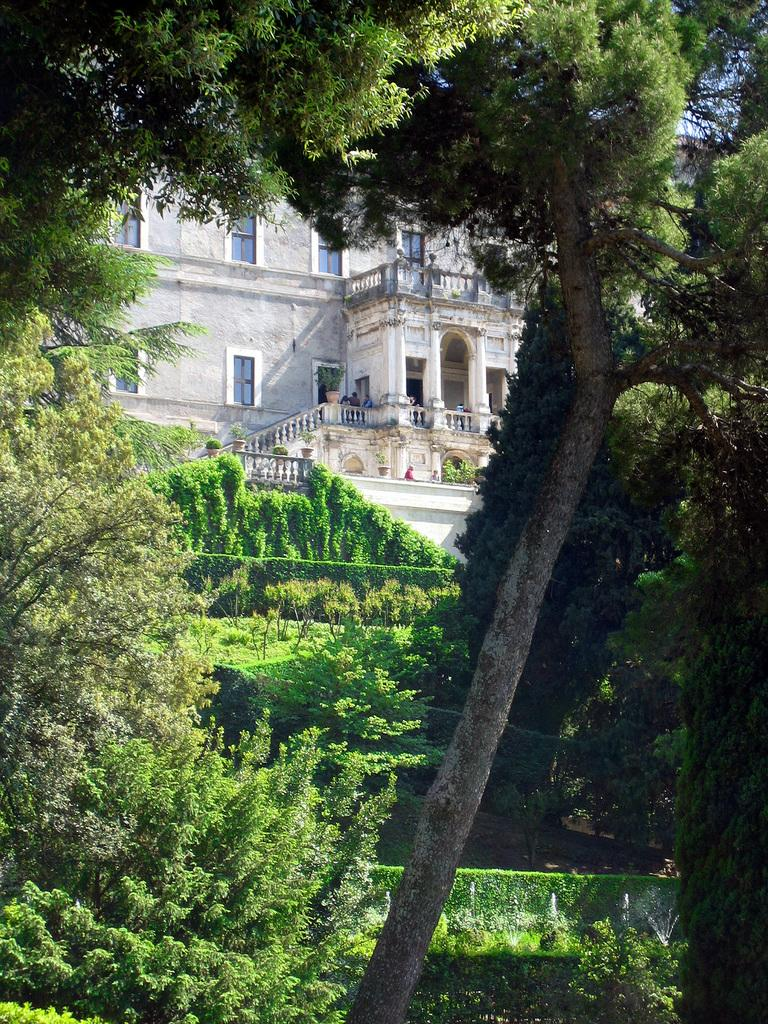What type of natural elements can be seen in the image? There are trees in the image. What type of structure is present in the image? There is a white building in the image. Can you describe the people inside the building? There are people inside the building, but their specific actions or appearances cannot be determined from the image. What architectural feature is present on the building? There are windows on the building. What is the chance of finding a light switch made of oranges in the image? There is no mention of a light switch or oranges in the image, so it is impossible to determine the likelihood of finding such an object. 